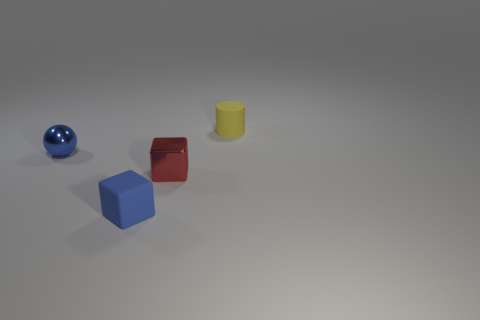Add 2 tiny matte cylinders. How many objects exist? 6 Subtract all cylinders. How many objects are left? 3 Add 2 rubber cylinders. How many rubber cylinders exist? 3 Subtract 0 red cylinders. How many objects are left? 4 Subtract all blue cubes. Subtract all blue things. How many objects are left? 1 Add 1 small spheres. How many small spheres are left? 2 